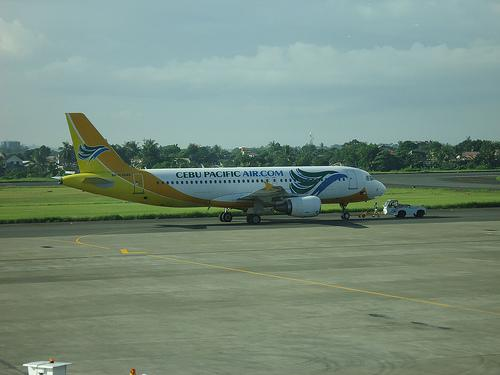Question: where was the picture taken?
Choices:
A. At the airport.
B. Park.
C. Parking lot.
D. On the sidewalk.
Answer with the letter. Answer: A Question: how many people are in the image?
Choices:
A. Two.
B. Three.
C. One.
D. Six.
Answer with the letter. Answer: C Question: what color is the airplane?
Choices:
A. Silver.
B. Yellow, blue and white.
C. Grey.
D. Orange.
Answer with the letter. Answer: B Question: who is in the image?
Choices:
A. A airport worker.
B. A train worker.
C. A pilot.
D. A ticket agent.
Answer with the letter. Answer: A Question: what is written on the airplane?
Choices:
A. Northwestern.
B. Delta.
C. US Air.
D. CEBU PACIFIC AIR.COM.
Answer with the letter. Answer: D Question: when was the picture taken?
Choices:
A. Before the plane landed.
B. After the plane took off.
C. Before the plane took off.
D. After the plane landed.
Answer with the letter. Answer: D 